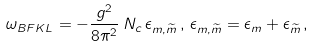<formula> <loc_0><loc_0><loc_500><loc_500>\omega _ { B F K L } = - \frac { g ^ { 2 } } { 8 \pi ^ { 2 } } \, N _ { c } \, \epsilon _ { m , \widetilde { m } } \, , \, \epsilon _ { m , \widetilde { m } } = \epsilon _ { m } + \epsilon _ { \widetilde { m } } \, ,</formula> 